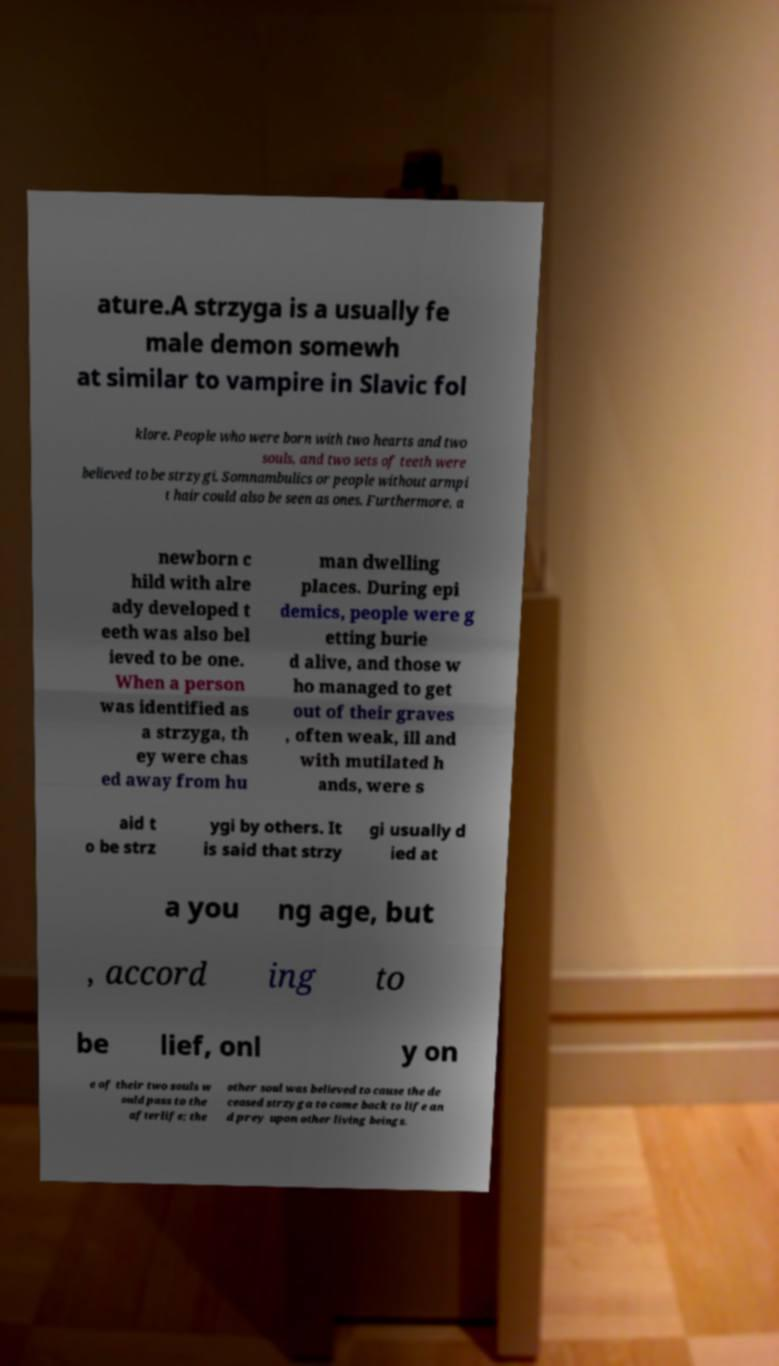Could you assist in decoding the text presented in this image and type it out clearly? ature.A strzyga is a usually fe male demon somewh at similar to vampire in Slavic fol klore. People who were born with two hearts and two souls, and two sets of teeth were believed to be strzygi. Somnambulics or people without armpi t hair could also be seen as ones. Furthermore, a newborn c hild with alre ady developed t eeth was also bel ieved to be one. When a person was identified as a strzyga, th ey were chas ed away from hu man dwelling places. During epi demics, people were g etting burie d alive, and those w ho managed to get out of their graves , often weak, ill and with mutilated h ands, were s aid t o be strz ygi by others. It is said that strzy gi usually d ied at a you ng age, but , accord ing to be lief, onl y on e of their two souls w ould pass to the afterlife; the other soul was believed to cause the de ceased strzyga to come back to life an d prey upon other living beings. 